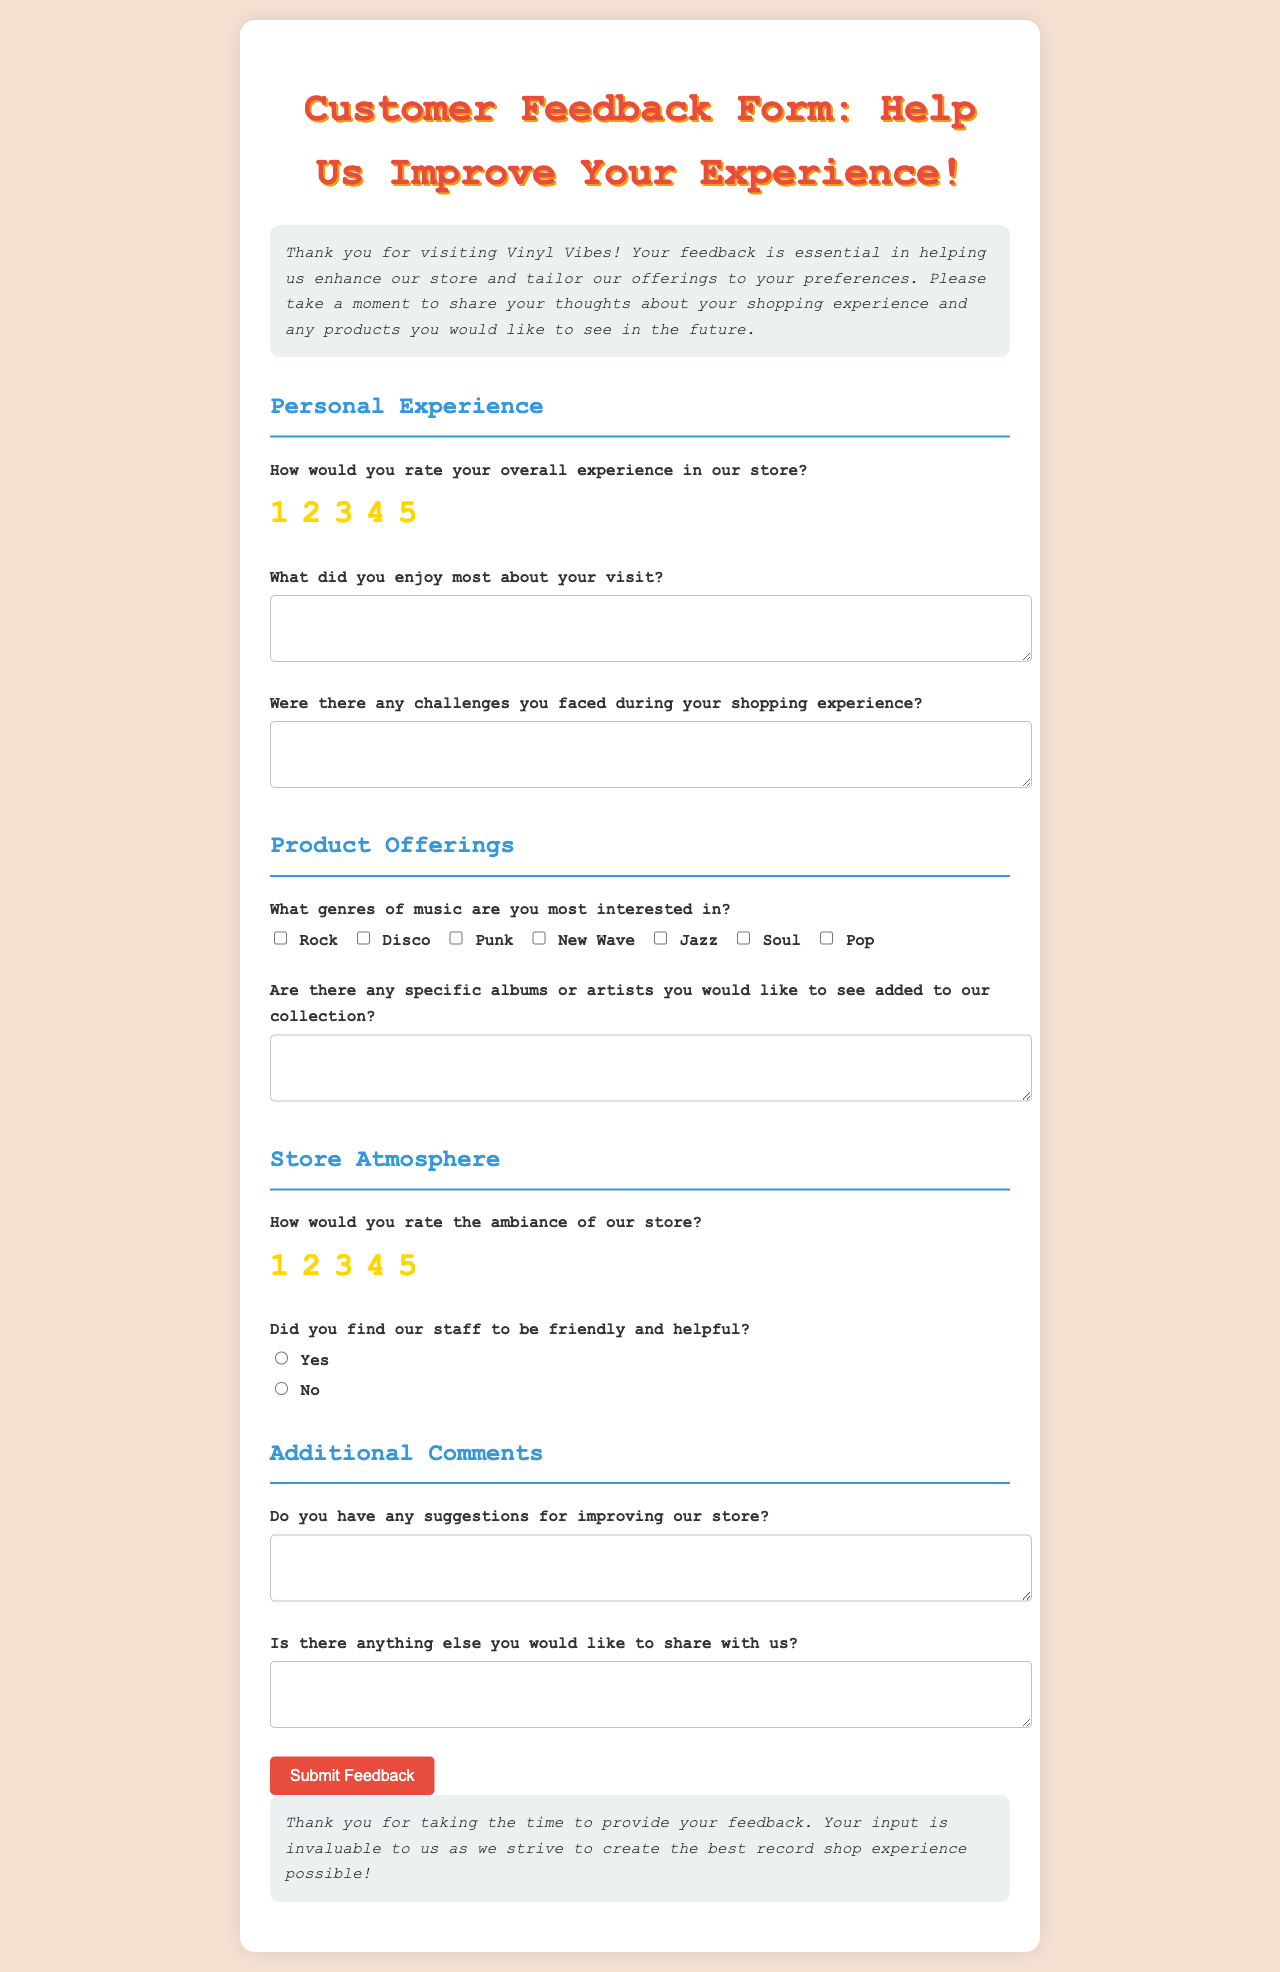How many rating options are there for overall experience? The document includes a rating scale with five options ranging from 1 to 5 stars.
Answer: 5 What genre is NOT listed as an interest option in the feedback form? The form includes various music genres, and one genre not mentioned is "Classical."
Answer: Classical What is the title of the feedback form? The feedback form is titled "Customer Feedback Form: Help Us Improve Your Experience!"
Answer: Customer Feedback Form: Help Us Improve Your Experience! What aspect of the store atmosphere can customers rate? Customers can rate the ambiance of the store using a scale from 1 to 5.
Answer: Ambiance What type of feedback does the "Additional Comments" section seek? This section invites customers to share any additional thoughts or suggestions beyond the structured questions.
Answer: Suggestions What color is used for the heading "Personal Experience"? The section heading is colored in a blue shade.
Answer: Blue Is there a section that specifically asks about staff friendliness? Yes, there is a question that inquires whether the staff was friendly and helpful.
Answer: Yes What element does the form emphasize at the beginning? The introduction highlights the importance of customer feedback for improving the store experience.
Answer: Importance of feedback How is the submit button styled in the document? The submit button features a red background color with white text and rounded corners.
Answer: Red background with white text 